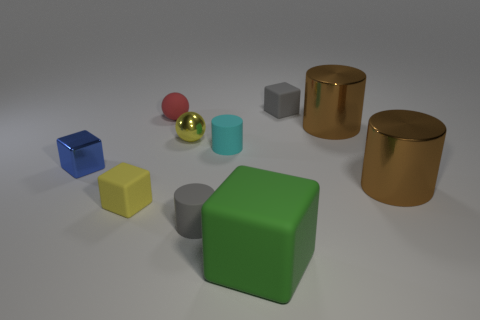What number of rubber things are both behind the cyan object and right of the small cyan matte cylinder?
Your response must be concise. 1. There is a blue object that is the same size as the yellow matte block; what is its shape?
Your response must be concise. Cube. What size is the green block?
Keep it short and to the point. Large. What material is the small blue cube behind the small gray object that is in front of the small cube on the right side of the red rubber sphere?
Ensure brevity in your answer.  Metal. What color is the big thing that is made of the same material as the yellow block?
Provide a succinct answer. Green. There is a tiny rubber cube to the right of the small gray rubber thing left of the tiny cyan rubber object; what number of tiny cylinders are behind it?
Offer a very short reply. 0. There is a cube that is the same color as the small metal ball; what is its material?
Offer a terse response. Rubber. How many things are small matte spheres right of the small blue object or spheres?
Make the answer very short. 2. There is a small rubber cube in front of the tiny yellow shiny ball; is its color the same as the small metallic ball?
Offer a very short reply. Yes. The small gray matte object that is in front of the tiny gray matte thing that is right of the green thing is what shape?
Provide a succinct answer. Cylinder. 